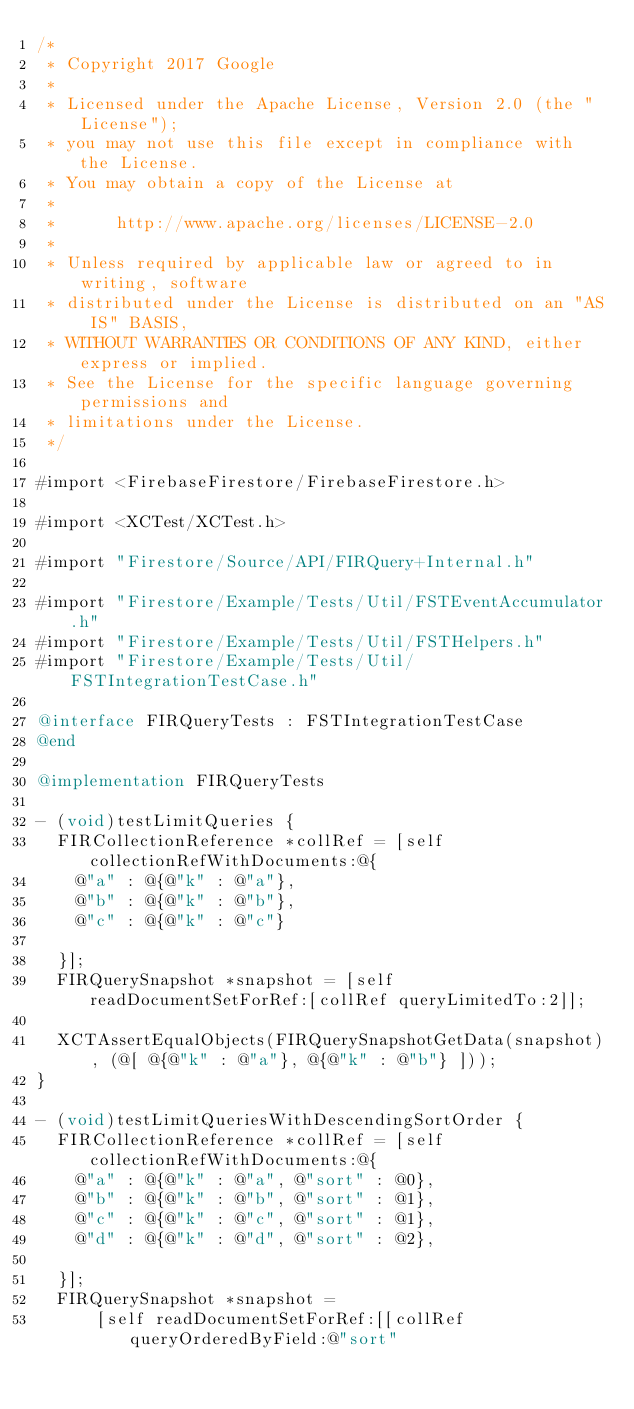<code> <loc_0><loc_0><loc_500><loc_500><_ObjectiveC_>/*
 * Copyright 2017 Google
 *
 * Licensed under the Apache License, Version 2.0 (the "License");
 * you may not use this file except in compliance with the License.
 * You may obtain a copy of the License at
 *
 *      http://www.apache.org/licenses/LICENSE-2.0
 *
 * Unless required by applicable law or agreed to in writing, software
 * distributed under the License is distributed on an "AS IS" BASIS,
 * WITHOUT WARRANTIES OR CONDITIONS OF ANY KIND, either express or implied.
 * See the License for the specific language governing permissions and
 * limitations under the License.
 */

#import <FirebaseFirestore/FirebaseFirestore.h>

#import <XCTest/XCTest.h>

#import "Firestore/Source/API/FIRQuery+Internal.h"

#import "Firestore/Example/Tests/Util/FSTEventAccumulator.h"
#import "Firestore/Example/Tests/Util/FSTHelpers.h"
#import "Firestore/Example/Tests/Util/FSTIntegrationTestCase.h"

@interface FIRQueryTests : FSTIntegrationTestCase
@end

@implementation FIRQueryTests

- (void)testLimitQueries {
  FIRCollectionReference *collRef = [self collectionRefWithDocuments:@{
    @"a" : @{@"k" : @"a"},
    @"b" : @{@"k" : @"b"},
    @"c" : @{@"k" : @"c"}

  }];
  FIRQuerySnapshot *snapshot = [self readDocumentSetForRef:[collRef queryLimitedTo:2]];

  XCTAssertEqualObjects(FIRQuerySnapshotGetData(snapshot), (@[ @{@"k" : @"a"}, @{@"k" : @"b"} ]));
}

- (void)testLimitQueriesWithDescendingSortOrder {
  FIRCollectionReference *collRef = [self collectionRefWithDocuments:@{
    @"a" : @{@"k" : @"a", @"sort" : @0},
    @"b" : @{@"k" : @"b", @"sort" : @1},
    @"c" : @{@"k" : @"c", @"sort" : @1},
    @"d" : @{@"k" : @"d", @"sort" : @2},

  }];
  FIRQuerySnapshot *snapshot =
      [self readDocumentSetForRef:[[collRef queryOrderedByField:@"sort"</code> 